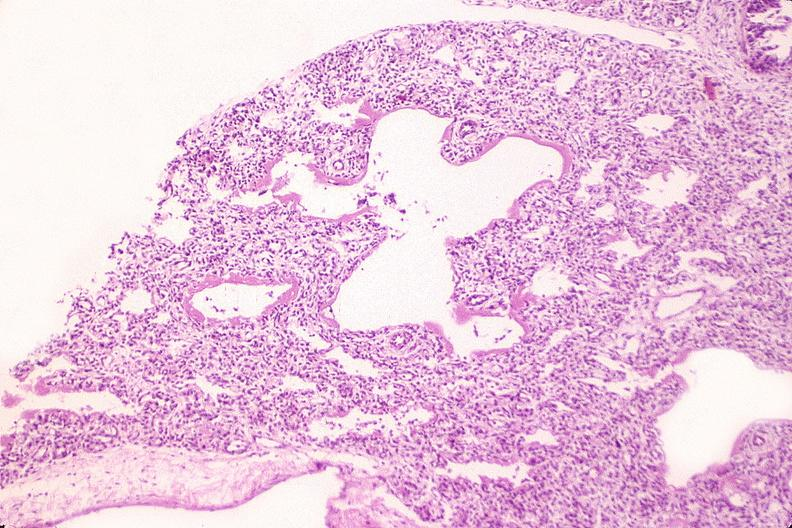what does this image show?
Answer the question using a single word or phrase. Lungs 